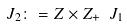Convert formula to latex. <formula><loc_0><loc_0><loc_500><loc_500>J _ { 2 } \colon = Z \times Z _ { + } \ J _ { 1 }</formula> 